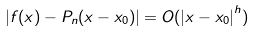Convert formula to latex. <formula><loc_0><loc_0><loc_500><loc_500>| f ( x ) - P _ { n } ( x - x _ { 0 } ) | = O ( { | x - x _ { 0 } | } ^ { h } )</formula> 